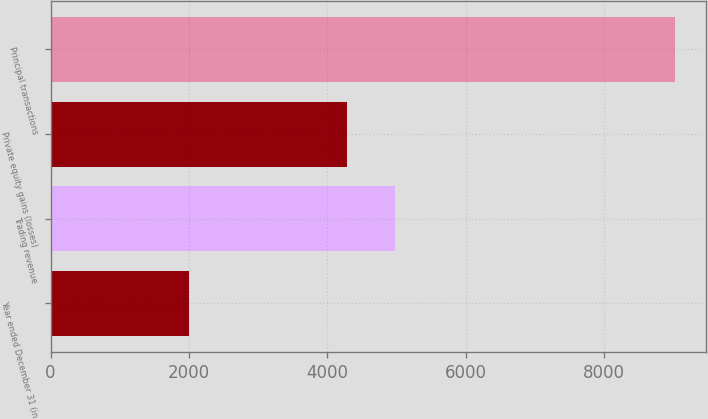Convert chart to OTSL. <chart><loc_0><loc_0><loc_500><loc_500><bar_chart><fcel>Year ended December 31 (in<fcel>Trading revenue<fcel>Private equity gains (losses)<fcel>Principal transactions<nl><fcel>2007<fcel>4979.8<fcel>4279<fcel>9015<nl></chart> 